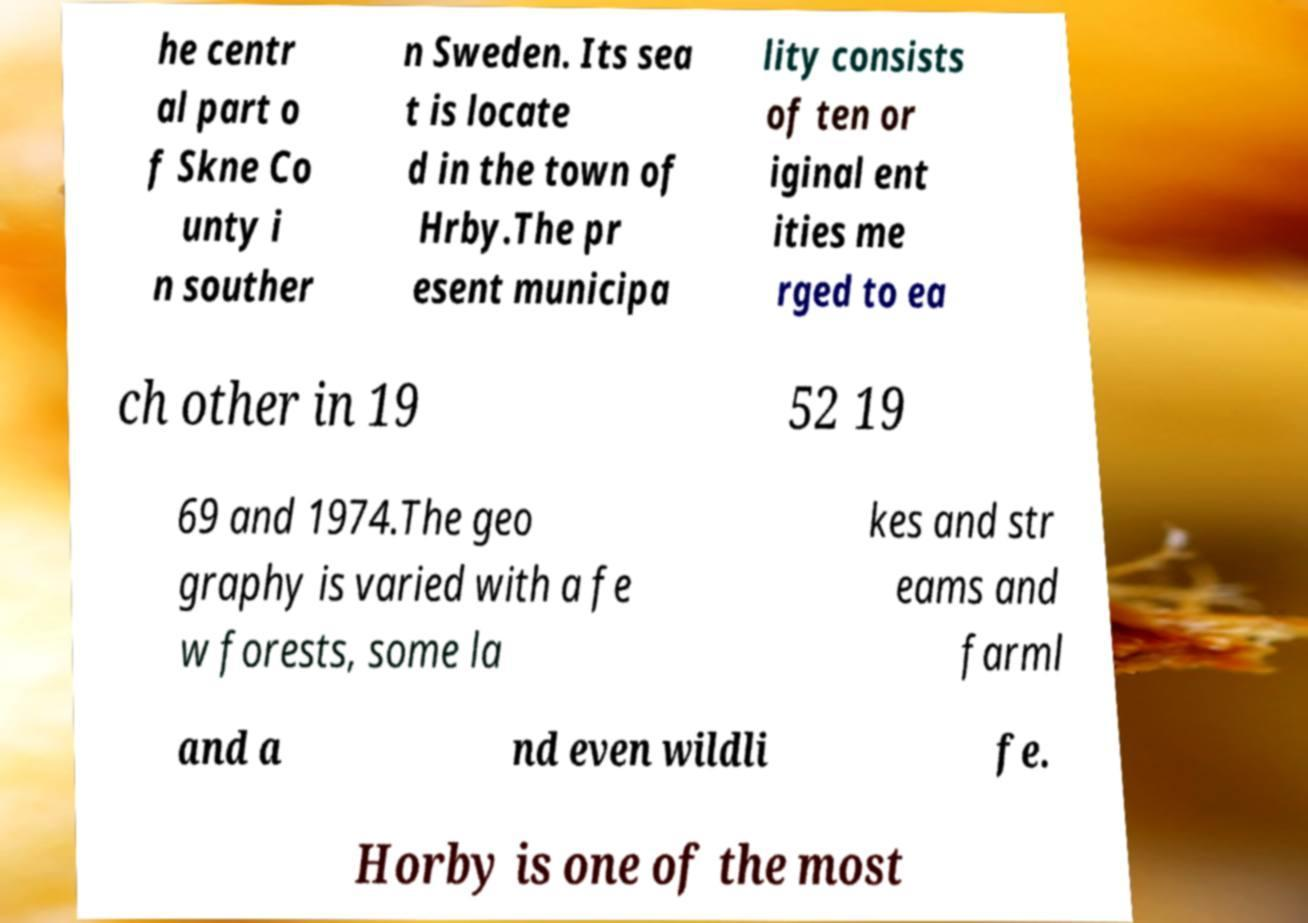There's text embedded in this image that I need extracted. Can you transcribe it verbatim? he centr al part o f Skne Co unty i n souther n Sweden. Its sea t is locate d in the town of Hrby.The pr esent municipa lity consists of ten or iginal ent ities me rged to ea ch other in 19 52 19 69 and 1974.The geo graphy is varied with a fe w forests, some la kes and str eams and farml and a nd even wildli fe. Horby is one of the most 